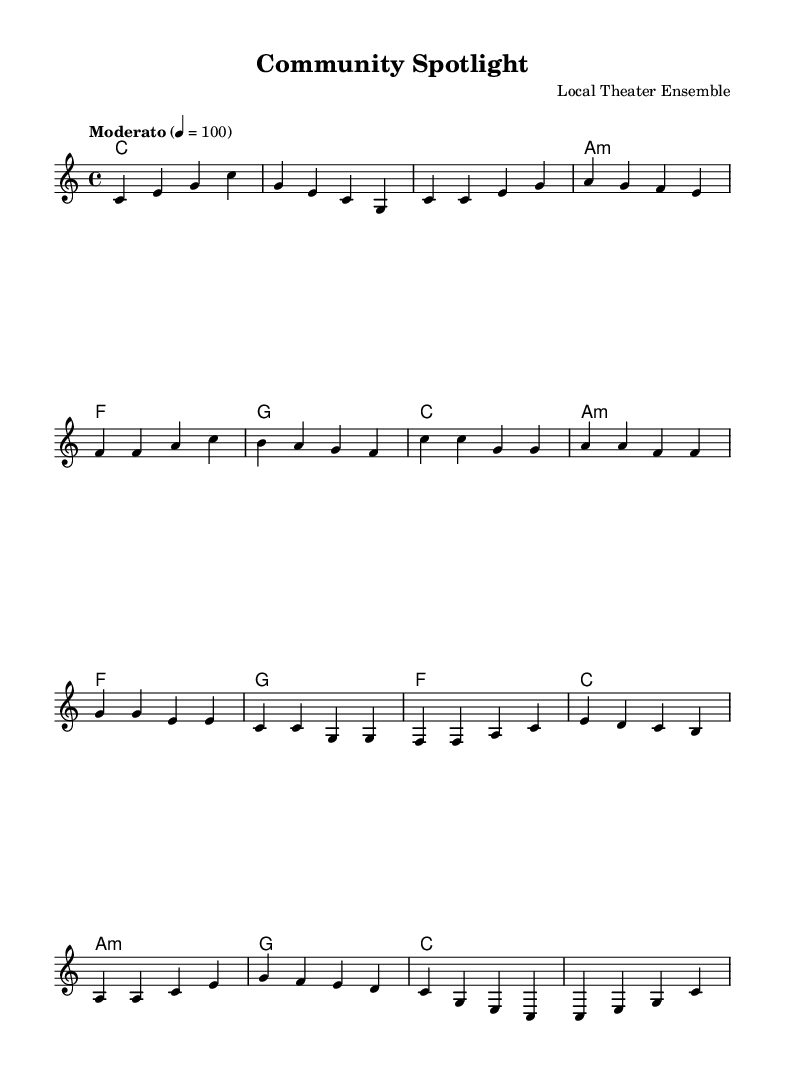What is the title of this piece? The title is indicated in the header section of the sheet music. It is stated as "Community Spotlight."
Answer: Community Spotlight What is the key signature of this music? The key signature is found in the global setup, and it indicates C major, which means there are no sharps or flats in the key signature.
Answer: C major What is the time signature of the piece? The time signature is also defined in the global section of the sheet music, shown as 4/4, which means there are four beats in a measure.
Answer: 4/4 What is the tempo marking for this piece? The tempo marking is found in the global setup, stating “Moderato” with a tempo of 100 beats per minute.
Answer: Moderato How many measures are in the chorus section? By examining the melody part of the score, the chorus consists of four measures as indicated by the melodic lines labeled above.
Answer: 4 What type of ensemble is performing this piece? The score header indicates that it is composed by a "Local Theater Ensemble," suggesting community performers are involved.
Answer: Local Theater Ensemble What is the structure of the song based on the sections present? The song includes an intro, verse, chorus, bridge, and outro, which can be inferred from the layout of the melody and the transitions marked in the sheet music.
Answer: Intro, Verse, Chorus, Bridge, Outro 